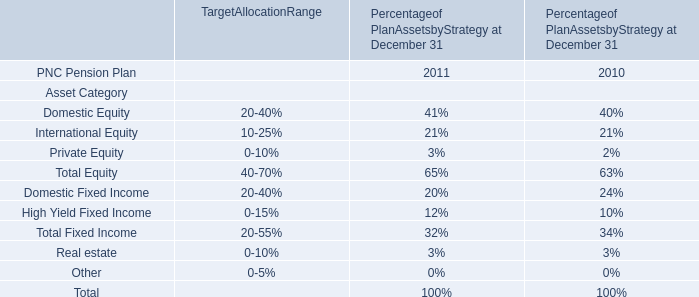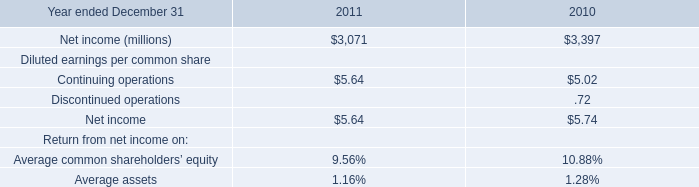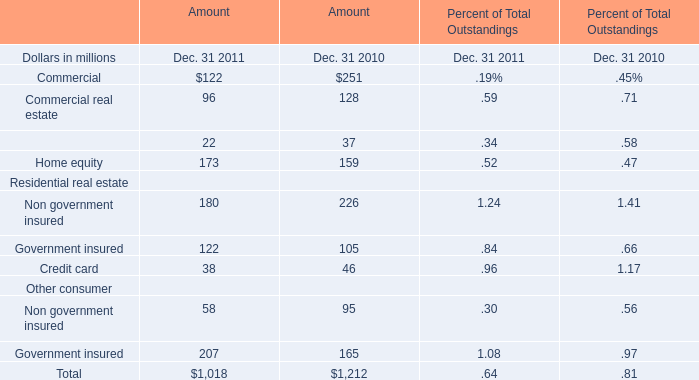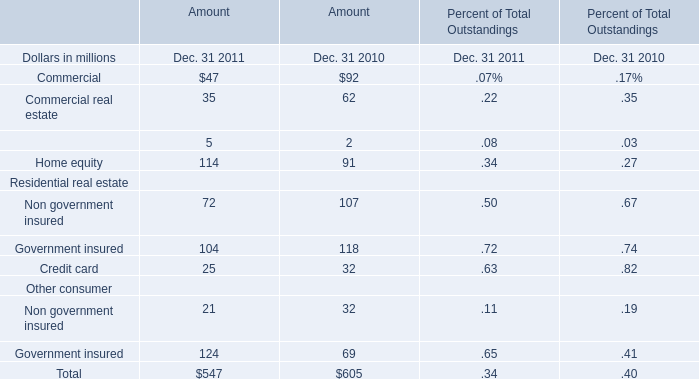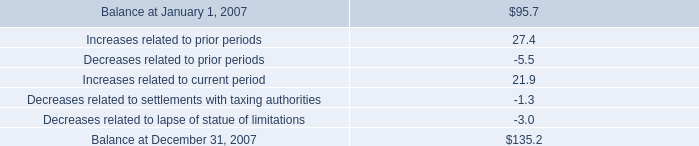What's the current increasing rate of Home equity? (in %) 
Computations: ((114 - 91) / 91)
Answer: 0.25275. 